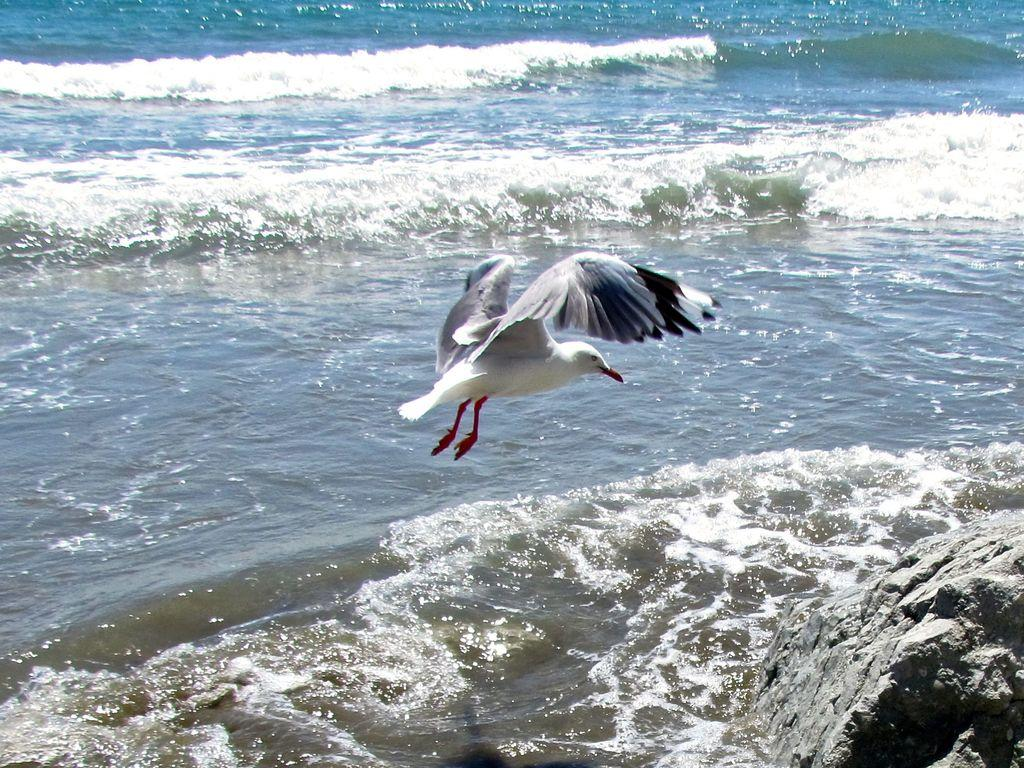What type of animal can be seen in the image? There is a bird in the image. What is the bird doing in the image? The bird is flying above the water surface. What can be seen on the right side of the image? There is a rock on the right side of the image. What type of crown is the bird wearing in the image? There is no crown present in the image; the bird is not wearing any accessories. 